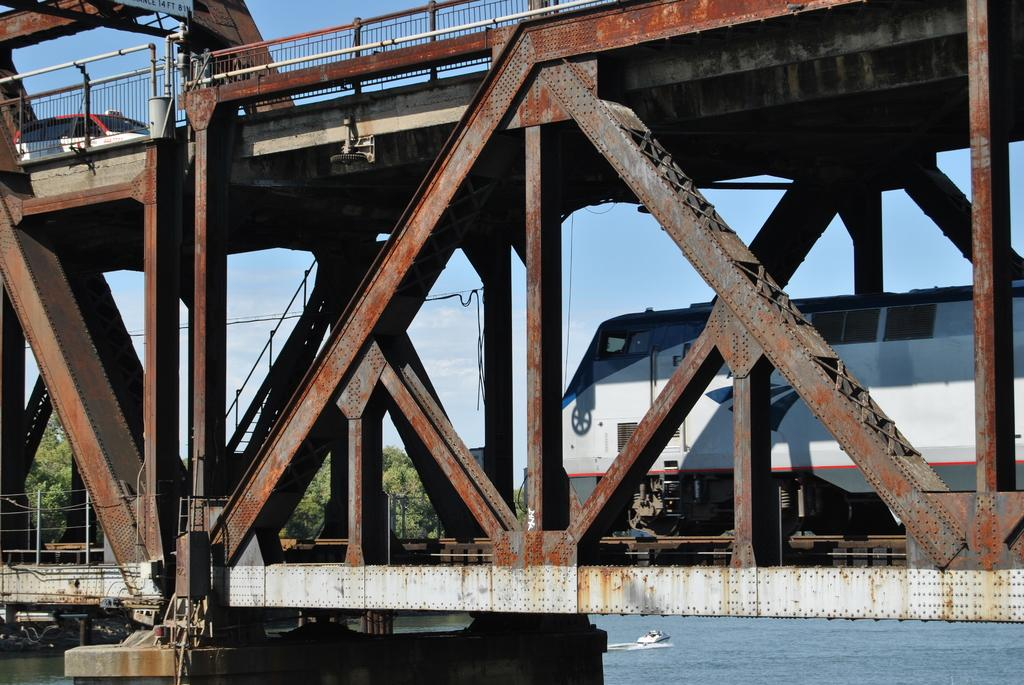What is the main subject of the image? The main subject of the image is a train. Can you describe the appearance of the train? The train is white and gray in color. What other structure is visible in the image? There is a bridge in the image. What type of vegetation can be seen in the background? The background of the image includes trees in green color. How would you describe the sky in the image? The sky is white and blue in color. How many legs can be seen supporting the table in the image? There is no table present in the image; it features a train and a bridge. 